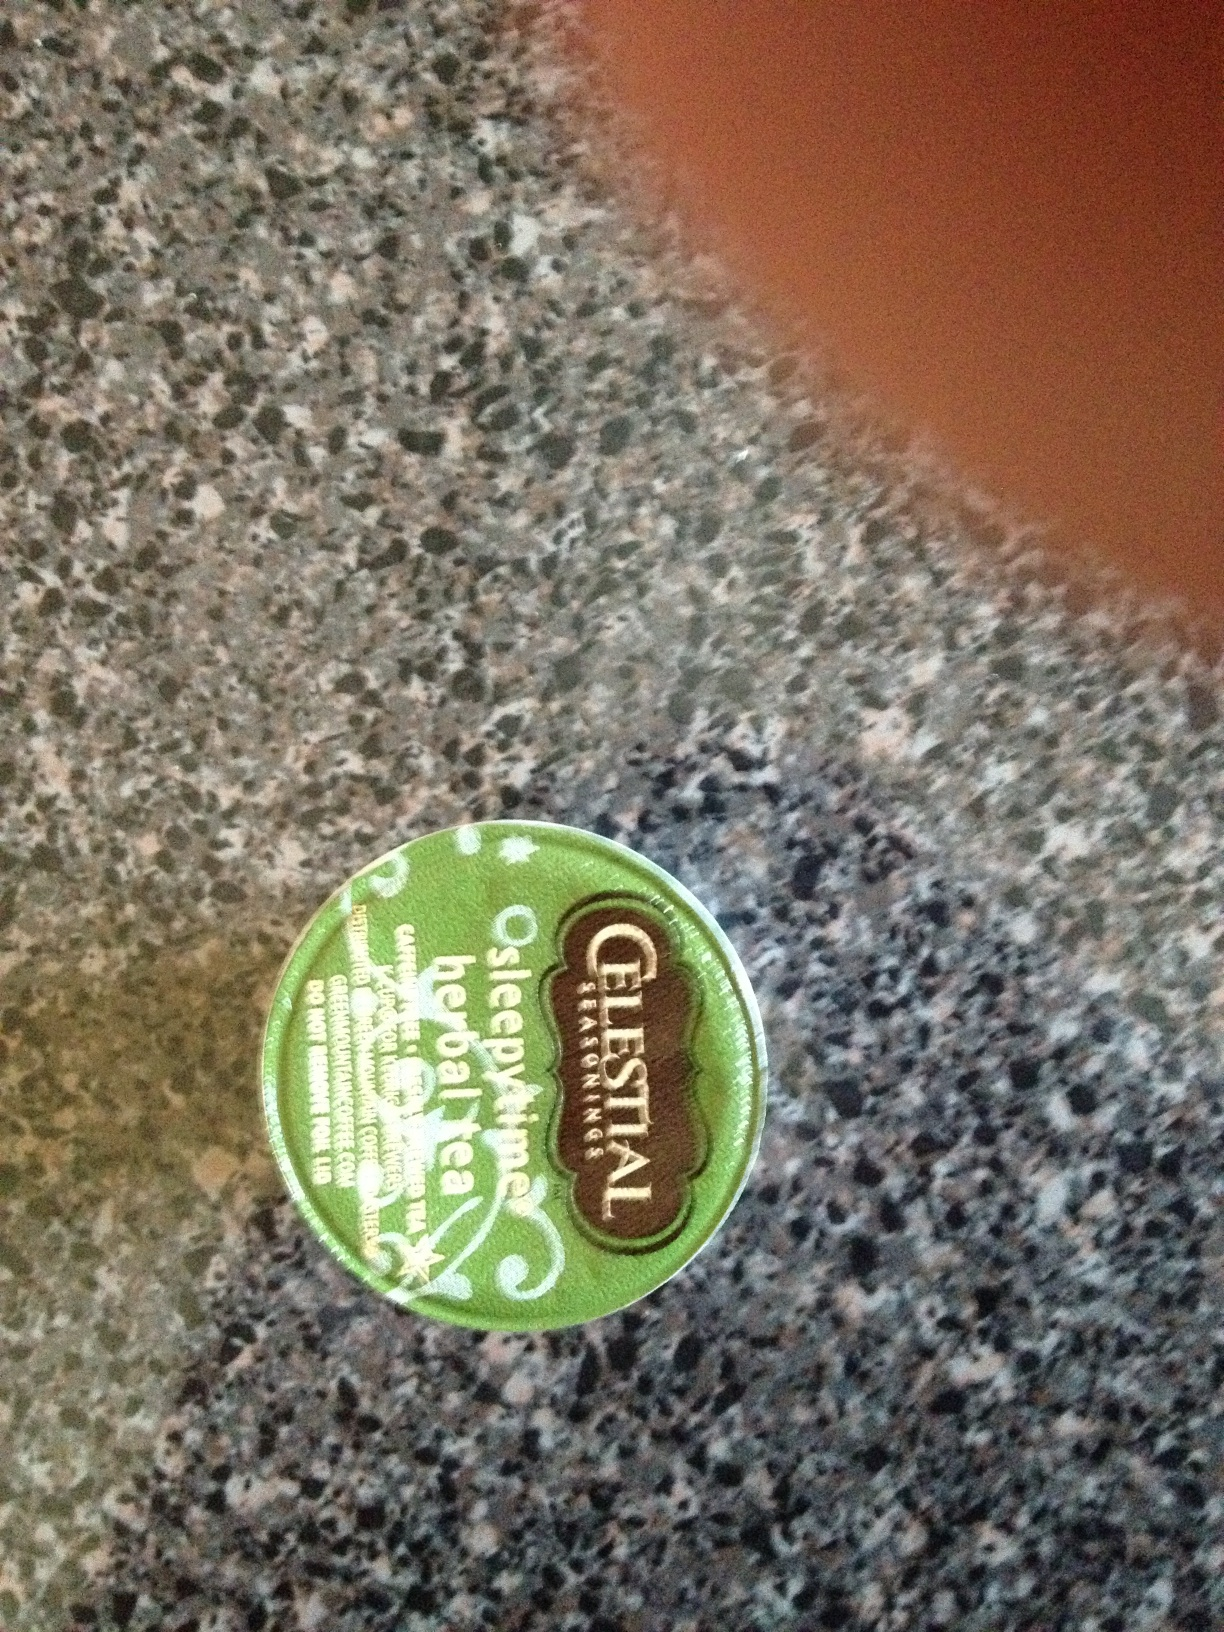What is the purpose of Sleepytime tea, and how might it help before bedtime? Sleepytime tea is designed as a natural remedy to help soothe the body and relax the mind before bed. The primary ingredients, like chamomile and spearmint, are known for their calming and digestive benefits, potentially promoting better sleep. 